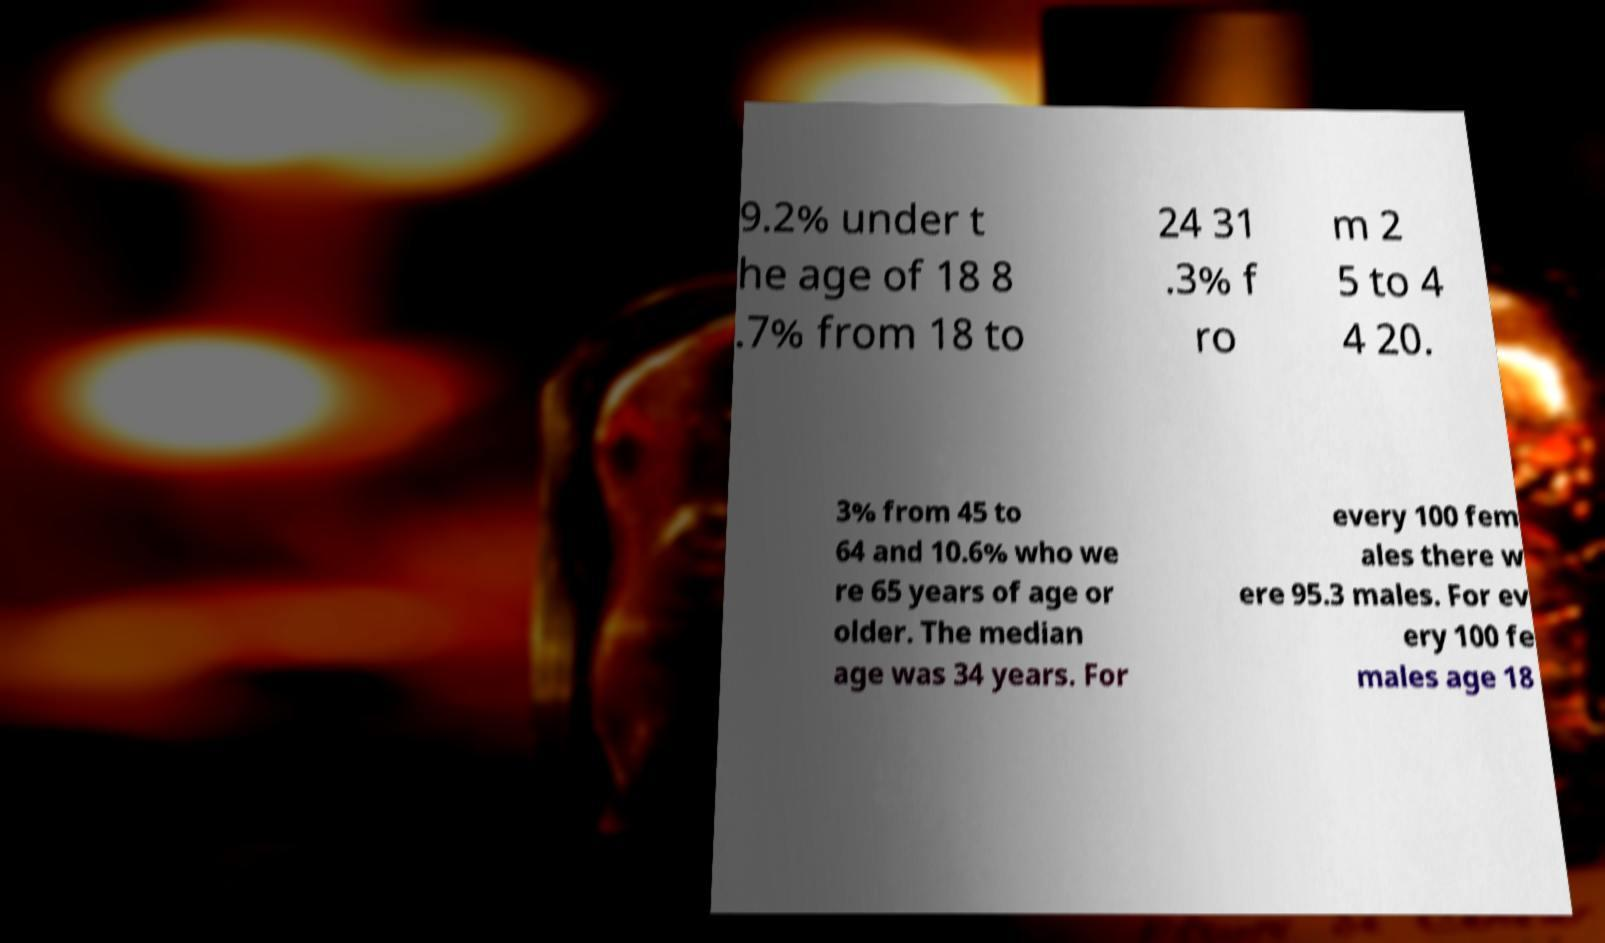There's text embedded in this image that I need extracted. Can you transcribe it verbatim? 9.2% under t he age of 18 8 .7% from 18 to 24 31 .3% f ro m 2 5 to 4 4 20. 3% from 45 to 64 and 10.6% who we re 65 years of age or older. The median age was 34 years. For every 100 fem ales there w ere 95.3 males. For ev ery 100 fe males age 18 